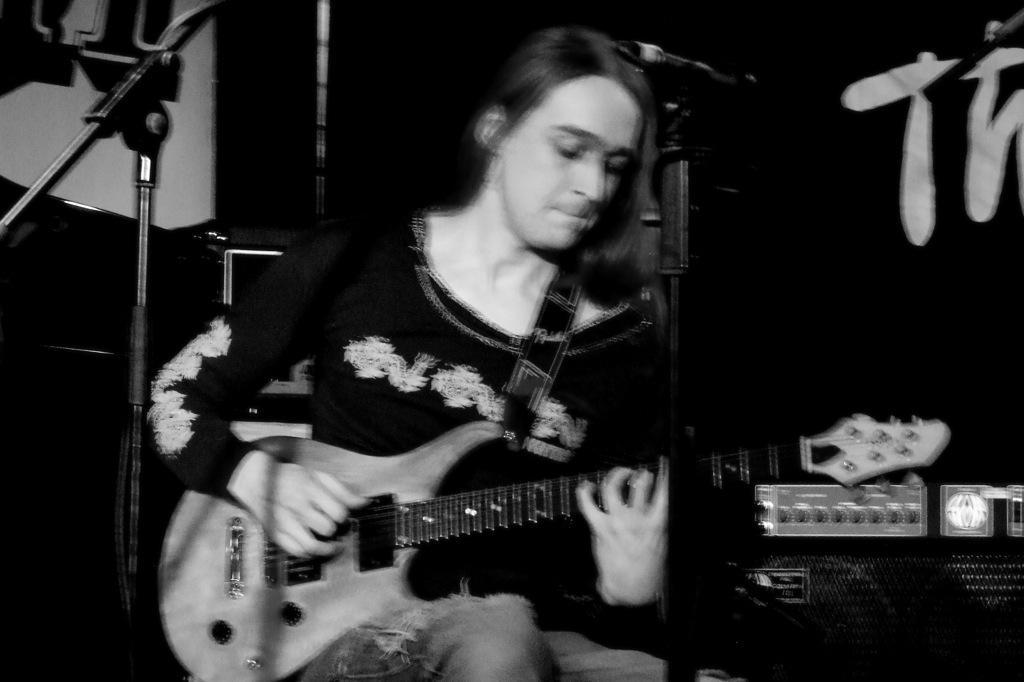In one or two sentences, can you explain what this image depicts? This is a black and white picture i could see a lady holding a guitar, in front of her there are mics and in the background there is black color text written. 